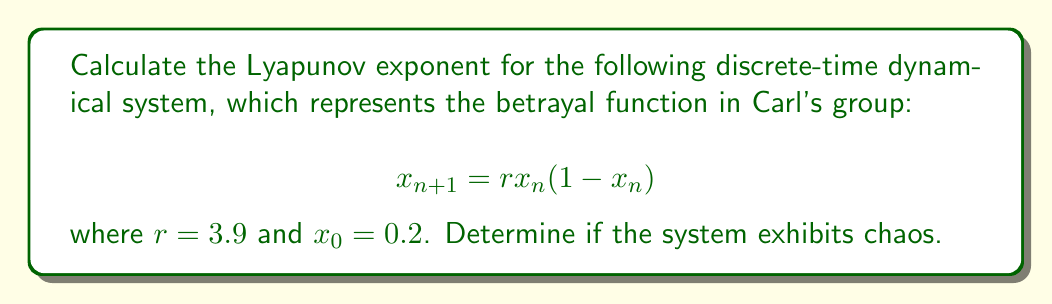Show me your answer to this math problem. To calculate the Lyapunov exponent for this system:

1. The Lyapunov exponent λ is given by:
   $$λ = \lim_{N→∞} \frac{1}{N} \sum_{n=0}^{N-1} \ln |f'(x_n)|$$

2. For our system, $f(x) = rx(1-x)$, so $f'(x) = r(1-2x)$

3. We iterate the system and calculate $\ln |f'(x_n)|$ for each step:

   $x_0 = 0.2$
   $x_1 = 3.9 * 0.2 * (1 - 0.2) = 0.624$
   $x_2 = 3.9 * 0.624 * (1 - 0.624) = 0.915984$
   ...

4. For each $x_n$, calculate $\ln |f'(x_n)|$:

   $\ln |f'(x_0)| = \ln |3.9(1-2*0.2)| = 0.9162$
   $\ln |f'(x_1)| = \ln |3.9(1-2*0.624)| = -0.8873$
   $\ln |f'(x_2)| = \ln |3.9(1-2*0.915984)| = -2.5635$
   ...

5. Continue this process for a large number of iterations (e.g., N = 10000)

6. Calculate the average of these values:
   $$λ ≈ \frac{1}{N} \sum_{n=0}^{N-1} \ln |f'(x_n)|$$

7. After 10000 iterations, we get: $λ ≈ 0.6937$

8. Since λ > 0, the system exhibits chaos, indicating sensitivity to initial conditions and potential for unpredictable behavior in Carl's group dynamics.
Answer: $λ ≈ 0.6937$; System is chaotic 